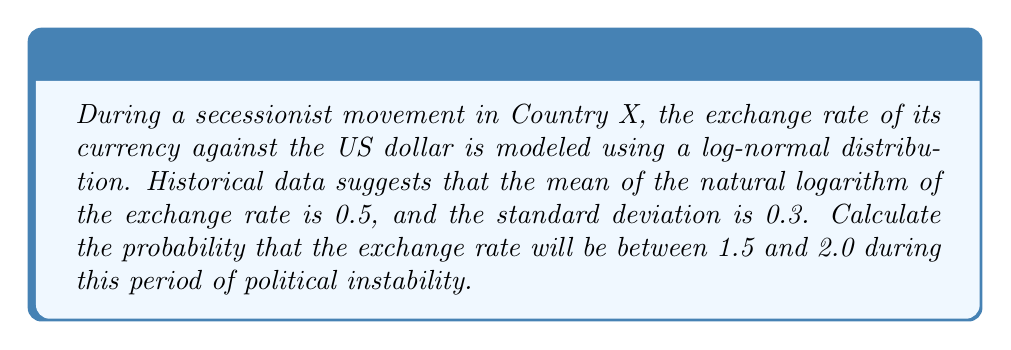What is the answer to this math problem? To solve this problem, we'll use the properties of the log-normal distribution and the standard normal distribution:

1) Let Y be the exchange rate. Then ln(Y) follows a normal distribution with mean μ = 0.5 and standard deviation σ = 0.3.

2) We need to find P(1.5 < Y < 2.0).

3) Transform this to the standard normal distribution:
   P(1.5 < Y < 2.0) = P(ln(1.5) < ln(Y) < ln(2.0))
                    = P((ln(1.5) - μ)/σ < (ln(Y) - μ)/σ < (ln(2.0) - μ)/σ)

4) Calculate the z-scores:
   z1 = (ln(1.5) - 0.5) / 0.3 = (0.4055 - 0.5) / 0.3 = -0.3150
   z2 = (ln(2.0) - 0.5) / 0.3 = (0.6931 - 0.5) / 0.3 = 0.6437

5) Now we need to find P(-0.3150 < Z < 0.6437), where Z is a standard normal variable.

6) Using the standard normal distribution table or a calculator:
   P(Z < 0.6437) - P(Z < -0.3150) = 0.7401 - 0.3764 = 0.3637

Therefore, the probability that the exchange rate will be between 1.5 and 2.0 during this period of political instability is approximately 0.3637 or 36.37%.
Answer: 0.3637 